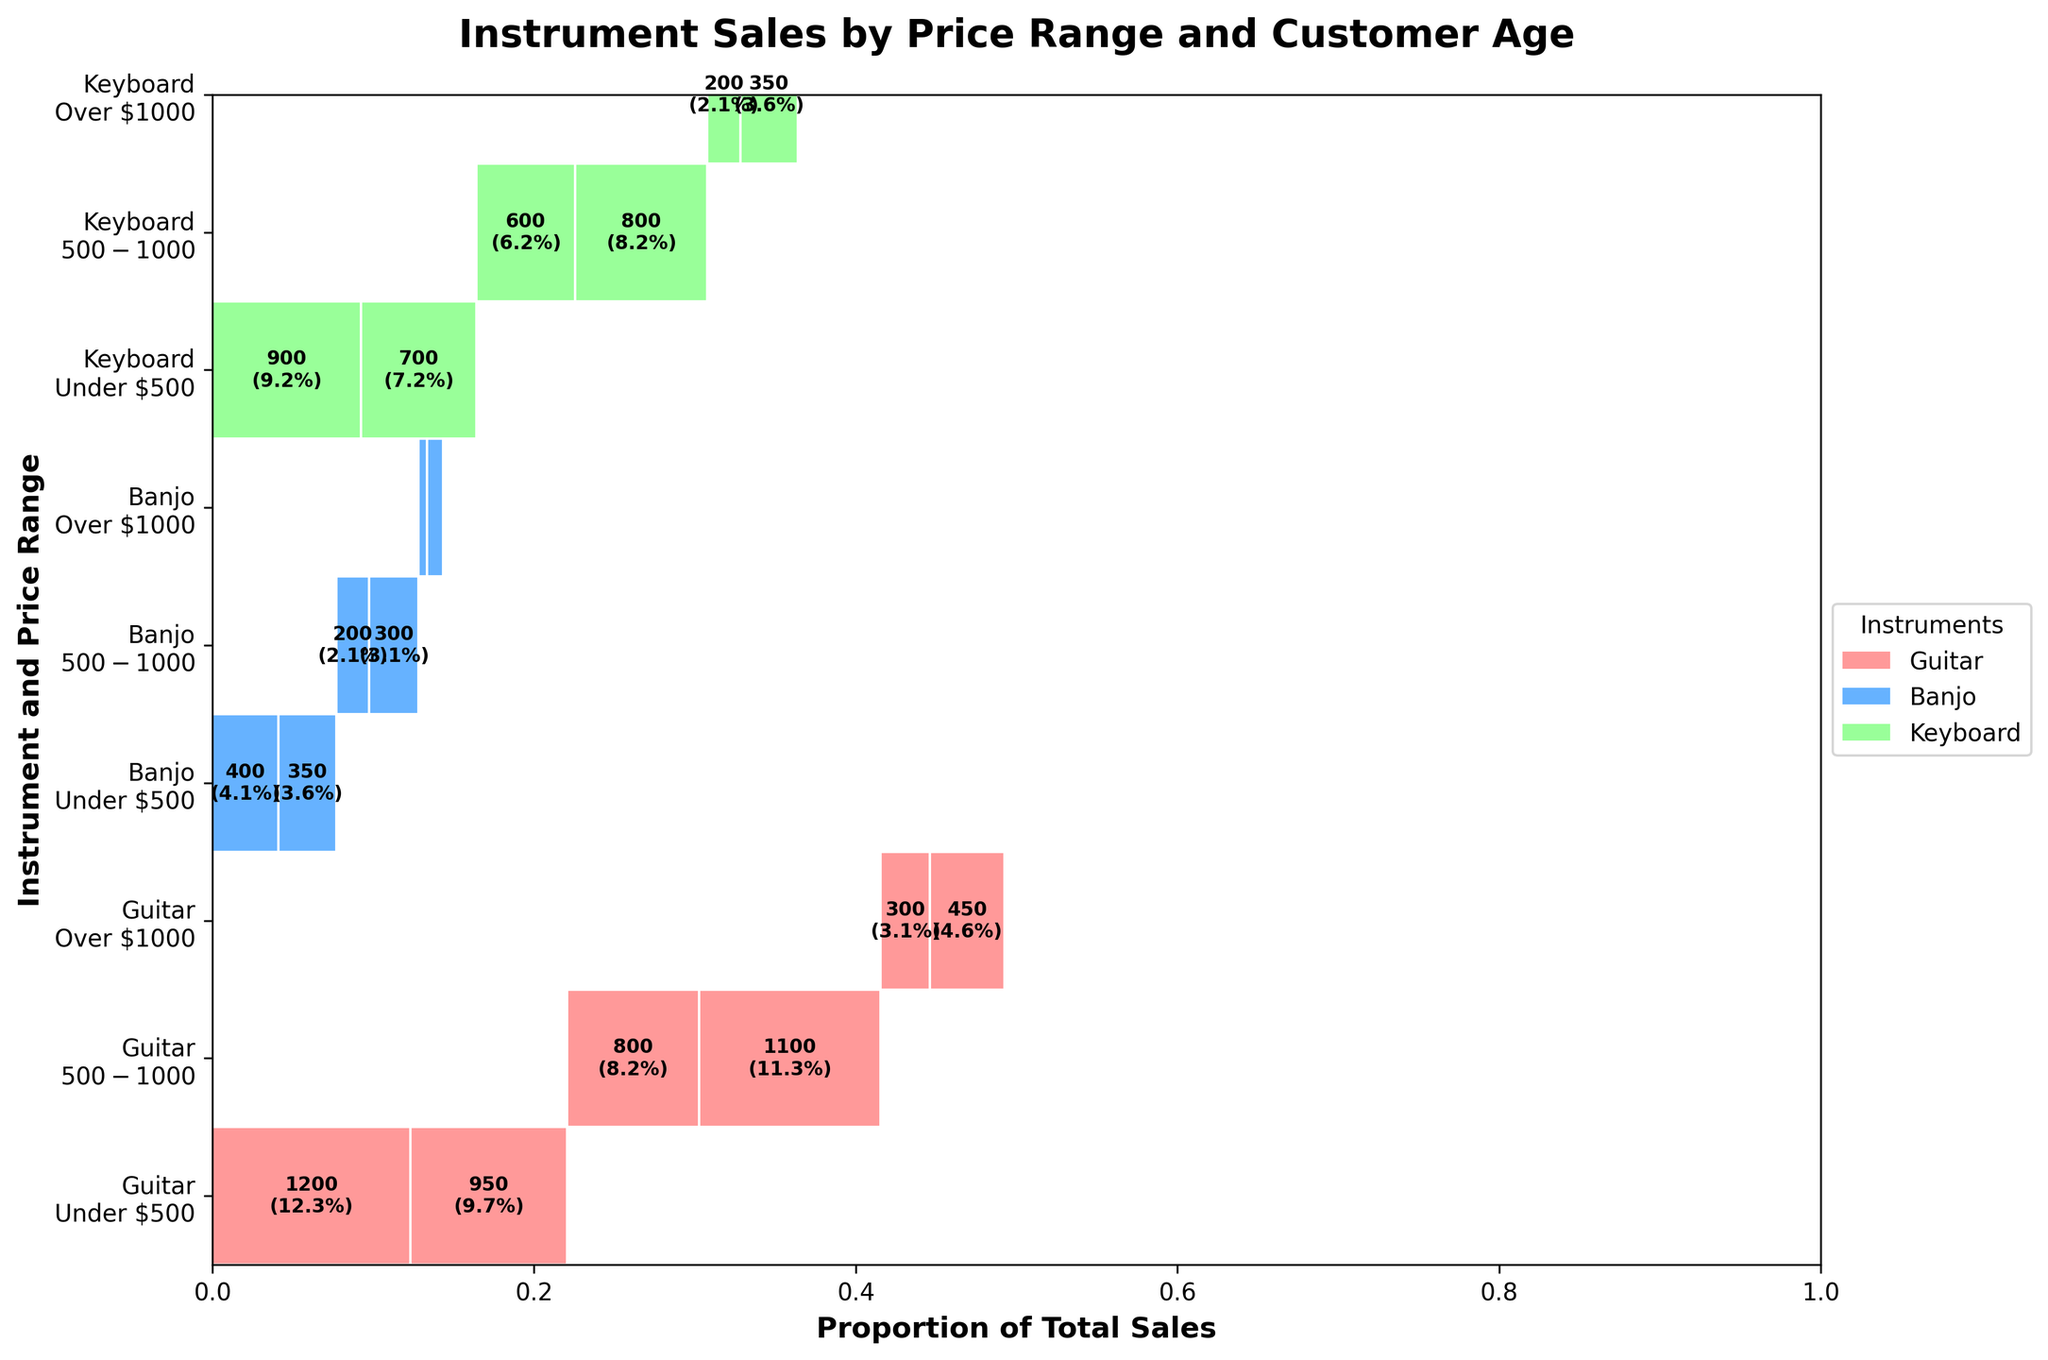What is the title of the figure? The title is usually displayed at the top of the figure. For this figure, the title should state the purpose of the figure.
Answer: Instrument Sales by Price Range and Customer Age Which instrument has the highest proportion of total sales in the '$500-$1000' price range? First, identify the '$500-$1000' price range in the figure. Then, check the proportions of total sales for each instrument within this range.
Answer: Guitar What is the total number of sales for keyboards in the 'Under $500' price range? Find the section corresponding to keyboards in the 'Under $500' price range and sum the values for both age groups (18-25 and 26-35).
Answer: 1600 Between age groups 18-25 and 26-35, which age group buys more guitars in the 'Under $500' price range? Look at the 'Under $500' price range for guitars and compare the proportions (or sales numbers) for the age groups 18-25 and 26-35.
Answer: 18-25 What percentage of banjo sales fall within the 'Over $1000' price range? Identify the 'Over $1000' price range section for banjos. Then, calculate the proportion of total sales that this section represents and convert it to a percentage.
Answer: 3.8% How do the sales of guitars in the 'Over $1000' price range compare between the two age groups? Locate the 'Over $1000' price range sections for guitars and compare the sales numbers for the age groups (18-25 and 26-35) side by side.
Answer: 26-35 > 18-25 Which instrument has the smallest proportion of total sales within each price range? Check each price range ('Under $500', '$500-$1000', 'Over $1000') and find the instrument with the smallest sales proportion in each.
Answer: Banjo Compare the number of sales between banjos in the '$500-$1000' price range and keyboards in the same range for both age groups. Sum up the sales numbers for banjos in the '$500-$1000' range (both age groups) and do the same for keyboards. Then, compare these totals.
Answer: Keyboards > Banjos What is the total number of sales for all instruments in the 'Over $1000' price range? Sum the sales values for all instruments within the 'Over $1000' price range across both age groups.
Answer: 1450 